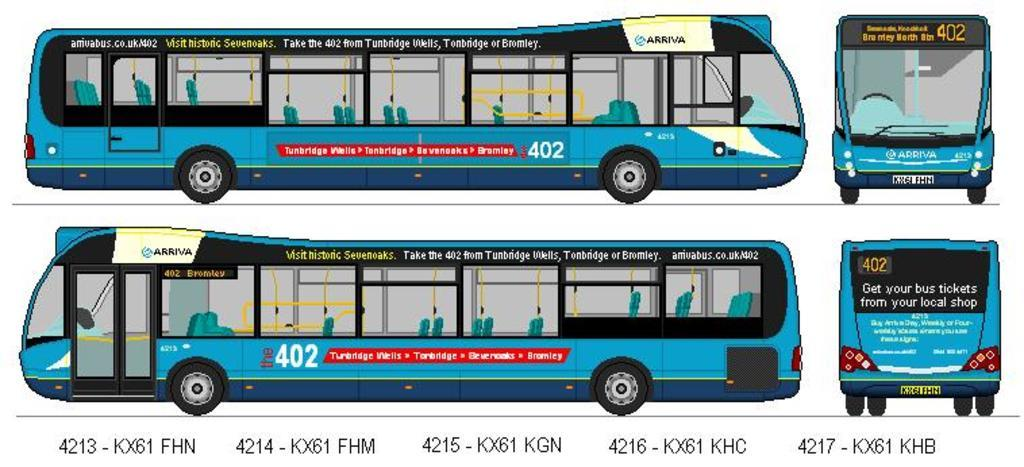What type of vehicles are depicted in the digital images in the image? There are digital images of buses in the image. What else can be seen in the image besides the digital images of buses? There is text present in the image. What type of shop can be seen in the image? There is no shop present in the image; it only contains digital images of buses and text. How many knots are tied in the image? There are no knots present in the image. 